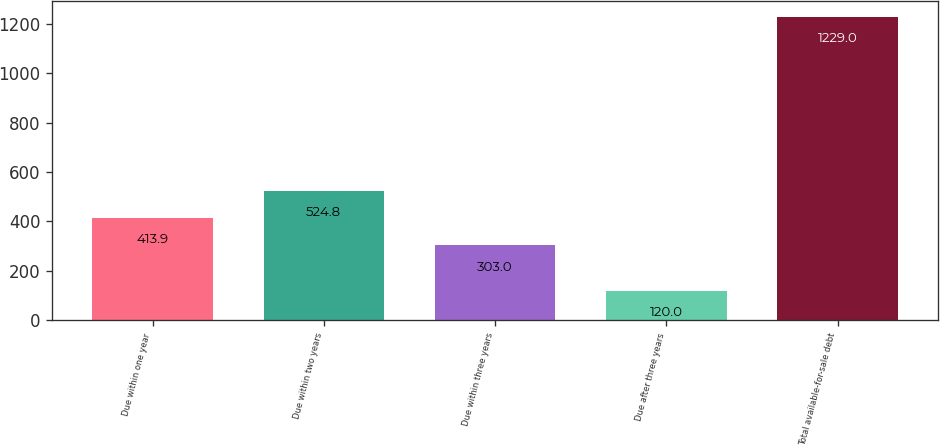<chart> <loc_0><loc_0><loc_500><loc_500><bar_chart><fcel>Due within one year<fcel>Due within two years<fcel>Due within three years<fcel>Due after three years<fcel>Total available-for-sale debt<nl><fcel>413.9<fcel>524.8<fcel>303<fcel>120<fcel>1229<nl></chart> 